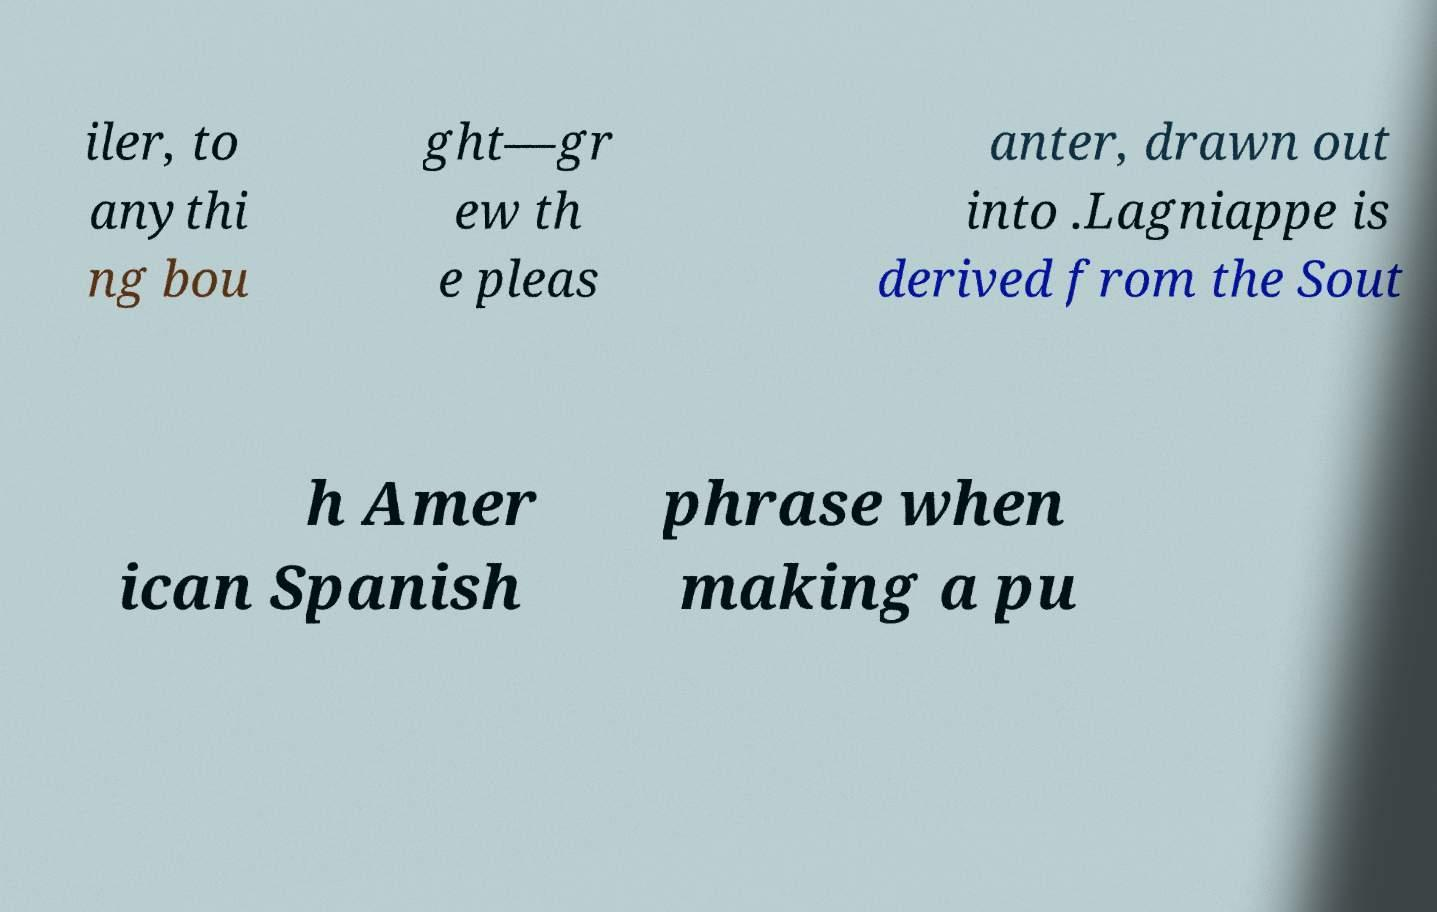For documentation purposes, I need the text within this image transcribed. Could you provide that? iler, to anythi ng bou ght—gr ew th e pleas anter, drawn out into .Lagniappe is derived from the Sout h Amer ican Spanish phrase when making a pu 